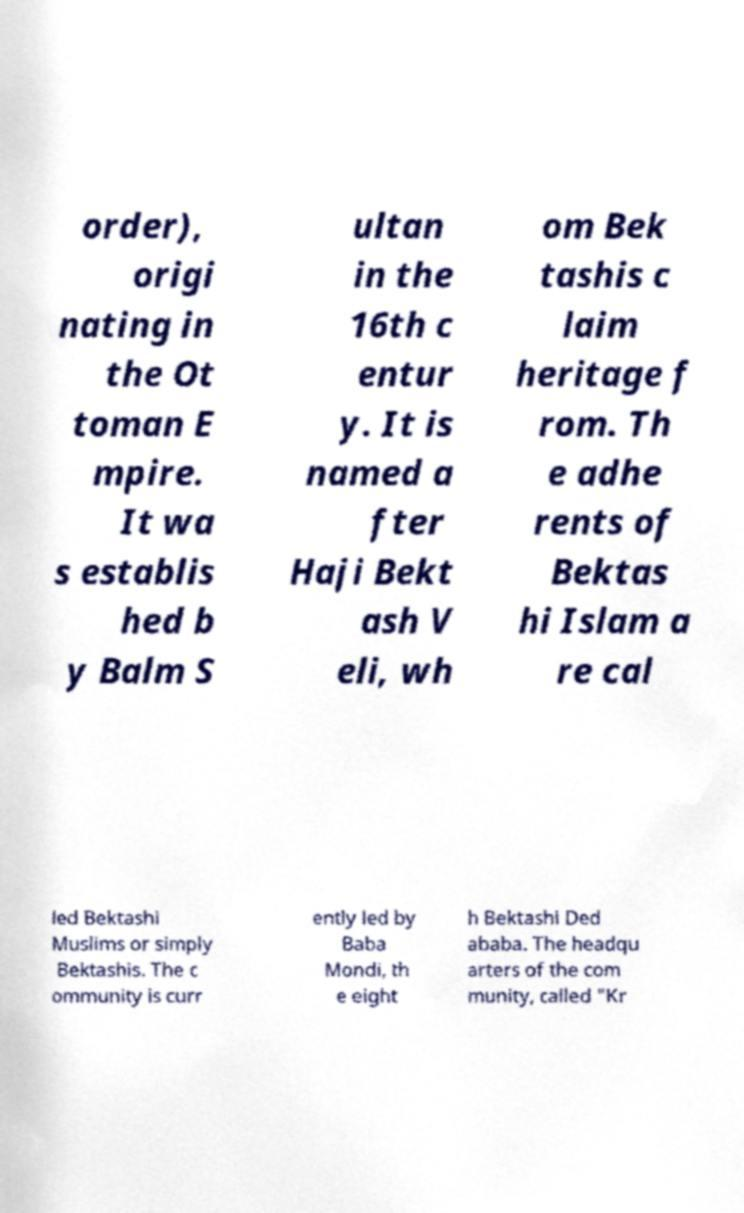Please identify and transcribe the text found in this image. order), origi nating in the Ot toman E mpire. It wa s establis hed b y Balm S ultan in the 16th c entur y. It is named a fter Haji Bekt ash V eli, wh om Bek tashis c laim heritage f rom. Th e adhe rents of Bektas hi Islam a re cal led Bektashi Muslims or simply Bektashis. The c ommunity is curr ently led by Baba Mondi, th e eight h Bektashi Ded ababa. The headqu arters of the com munity, called "Kr 